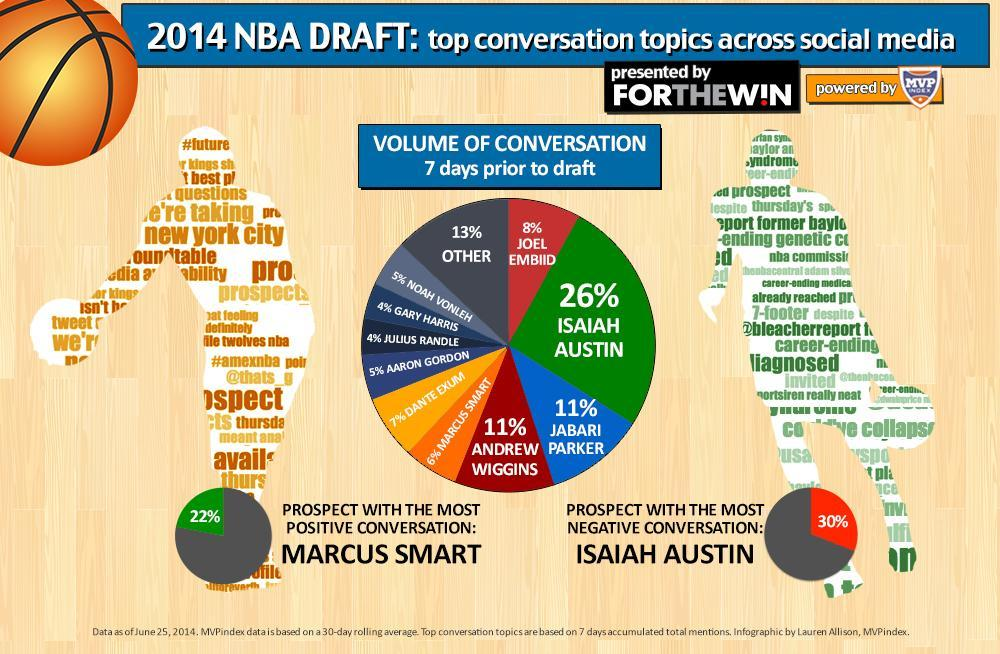Who had the most of negative conversation?
Answer the question with a short phrase. Isaiah Austin What percentage of conversation was about Andrew Wiggins? 11% Who is the prospect with most of positive conversation? Marcus Smart What percentage of positive conversation did Marcus Smart have? 22% What percentage of negative conversation did Isaiah Austin have? 30% Who had the highest volume of conversation 7 days prior to draft? Isaiah Austin Who are the players with more than 10% of volume of conversation? Isaiah Austin, Andrew Wiggins, Jabari Parker What percentage of conversation was about Joel Embiid? 8% Who were the individual players with less than 5% of the volume of conversation? Gary Harris, Julius Randle 